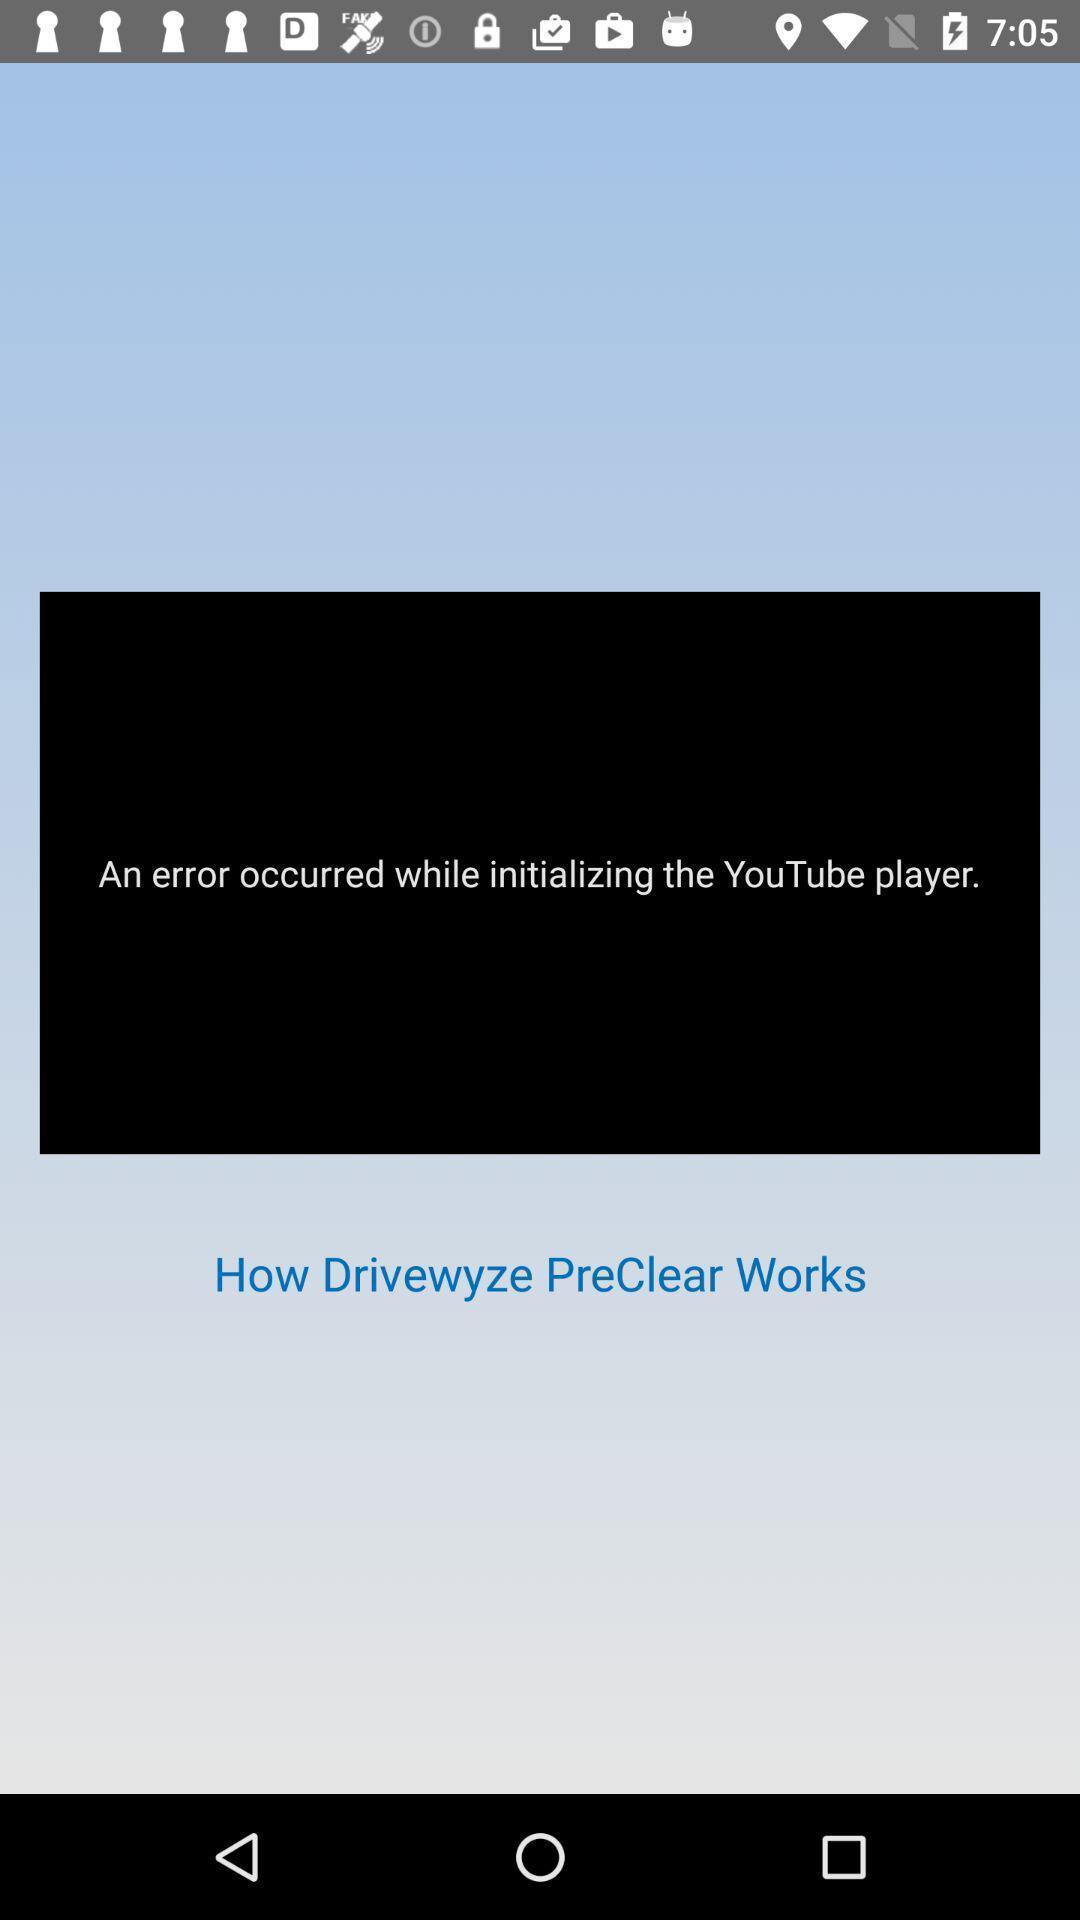Provide a textual representation of this image. Screen displaying the screen page of a trucker app. 